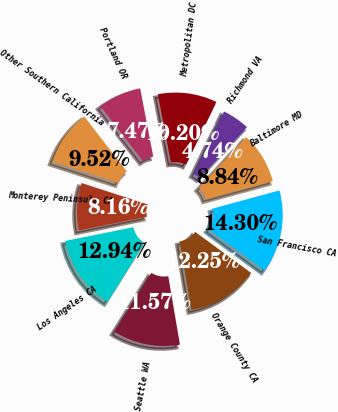Convert chart. <chart><loc_0><loc_0><loc_500><loc_500><pie_chart><fcel>San Francisco CA<fcel>Orange County CA<fcel>Seattle WA<fcel>Los Angeles CA<fcel>Monterey Peninsula CA<fcel>Other Southern California<fcel>Portland OR<fcel>Metropolitan DC<fcel>Richmond VA<fcel>Baltimore MD<nl><fcel>14.3%<fcel>12.25%<fcel>11.57%<fcel>12.94%<fcel>8.16%<fcel>9.52%<fcel>7.47%<fcel>10.2%<fcel>4.74%<fcel>8.84%<nl></chart> 